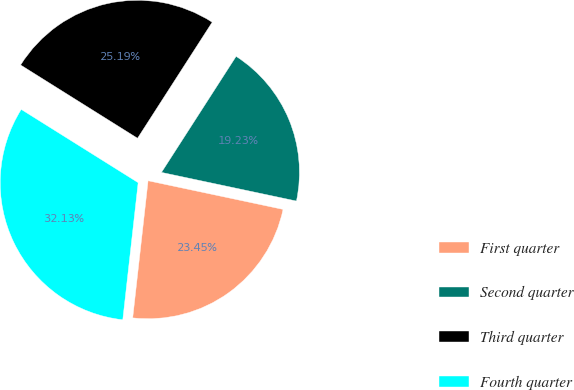<chart> <loc_0><loc_0><loc_500><loc_500><pie_chart><fcel>First quarter<fcel>Second quarter<fcel>Third quarter<fcel>Fourth quarter<nl><fcel>23.45%<fcel>19.23%<fcel>25.19%<fcel>32.13%<nl></chart> 